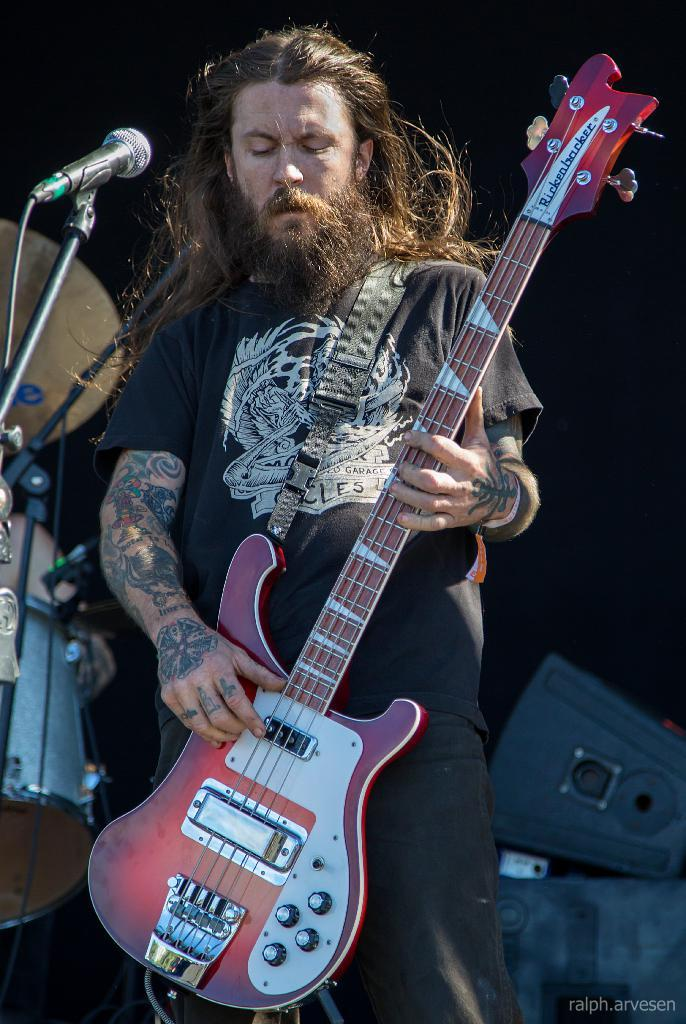Who is the main subject in the image? There is a man in the image. What is the man doing in the image? The man is standing and playing a guitar. What object is in front of the man? There is a microphone in front of the man. What type of butter is being used to lubricate the guitar strings in the image? There is no butter present in the image, and the guitar strings do not require lubrication. 